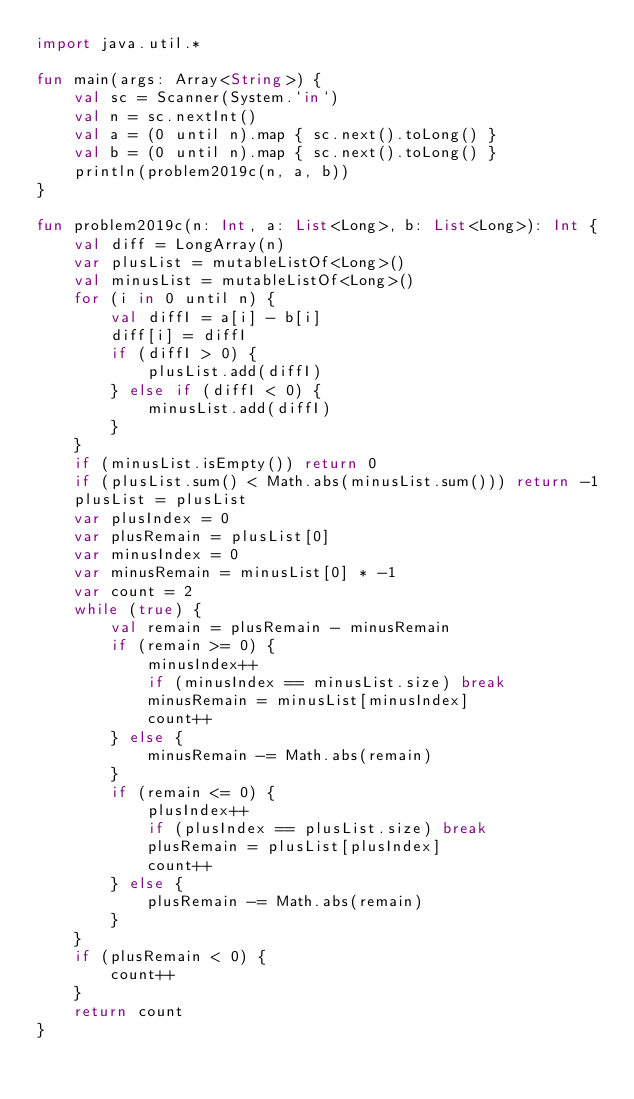Convert code to text. <code><loc_0><loc_0><loc_500><loc_500><_Kotlin_>import java.util.*

fun main(args: Array<String>) {
    val sc = Scanner(System.`in`)
    val n = sc.nextInt()
    val a = (0 until n).map { sc.next().toLong() }
    val b = (0 until n).map { sc.next().toLong() }
    println(problem2019c(n, a, b))
}

fun problem2019c(n: Int, a: List<Long>, b: List<Long>): Int {
    val diff = LongArray(n)
    var plusList = mutableListOf<Long>()
    val minusList = mutableListOf<Long>()
    for (i in 0 until n) {
        val diffI = a[i] - b[i]
        diff[i] = diffI
        if (diffI > 0) {
            plusList.add(diffI)
        } else if (diffI < 0) {
            minusList.add(diffI)
        }
    }
    if (minusList.isEmpty()) return 0
    if (plusList.sum() < Math.abs(minusList.sum())) return -1
    plusList = plusList
    var plusIndex = 0
    var plusRemain = plusList[0]
    var minusIndex = 0
    var minusRemain = minusList[0] * -1
    var count = 2
    while (true) {
        val remain = plusRemain - minusRemain
        if (remain >= 0) {
            minusIndex++
            if (minusIndex == minusList.size) break
            minusRemain = minusList[minusIndex]
            count++
        } else {
            minusRemain -= Math.abs(remain)
        }
        if (remain <= 0) {
            plusIndex++
            if (plusIndex == plusList.size) break
            plusRemain = plusList[plusIndex]
            count++
        } else {
            plusRemain -= Math.abs(remain)
        }
    }
    if (plusRemain < 0) {
        count++
    }
    return count
}</code> 